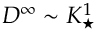Convert formula to latex. <formula><loc_0><loc_0><loc_500><loc_500>D ^ { \infty } \sim K _ { ^ { * } } ^ { 1 }</formula> 